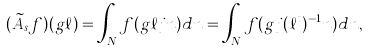Convert formula to latex. <formula><loc_0><loc_0><loc_500><loc_500>( \widetilde { A } _ { s } f ) ( g \ell ) = \int _ { N } f ( g \ell j n ) d n = \int _ { N } f ( g j ( \ell ^ { t } ) ^ { - 1 } n ) d n ,</formula> 